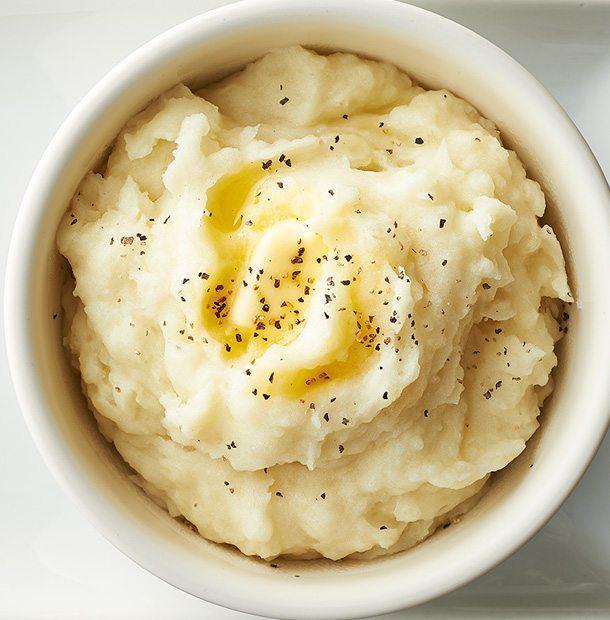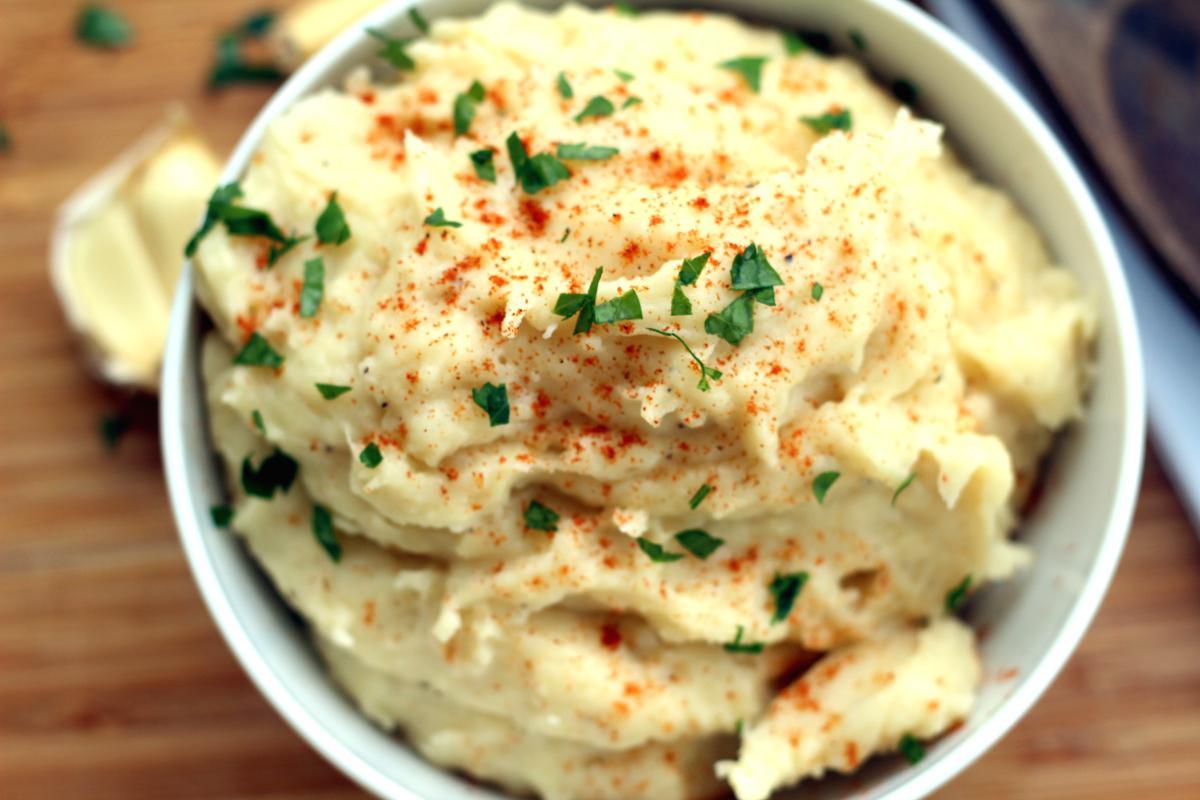The first image is the image on the left, the second image is the image on the right. Analyze the images presented: Is the assertion "Mashed potatoes in each image are served in round white dishes with flecks of garnish." valid? Answer yes or no. Yes. The first image is the image on the left, the second image is the image on the right. Examine the images to the left and right. Is the description "A fork sits near a plate of food in one of the images." accurate? Answer yes or no. No. 